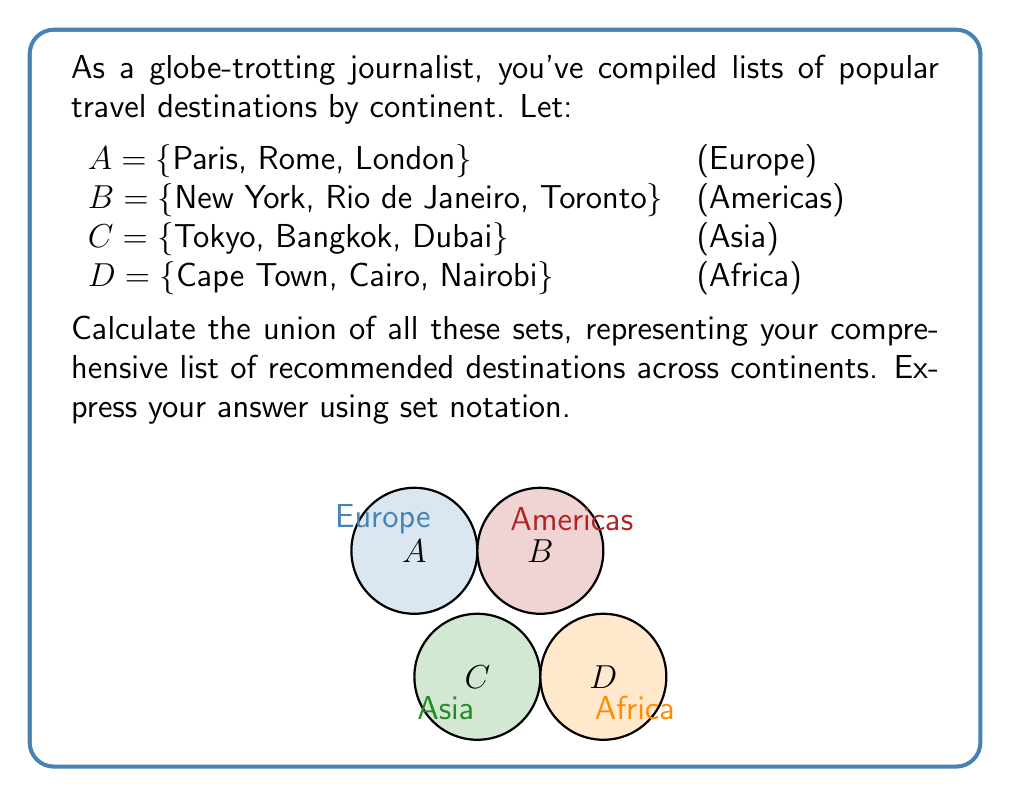Teach me how to tackle this problem. To calculate the union of these sets, we need to combine all unique elements from each set. The union operation is denoted by the symbol $\cup$. Let's approach this step-by-step:

1) First, let's recall the definition of union:
   The union of sets X and Y, denoted X $\cup$ Y, is the set of all elements that are in X, or in Y, or in both.

2) In our case, we need to find A $\cup$ B $\cup$ C $\cup$ D.

3) We can start by listing all elements from set A:
   {Paris, Rome, London}

4) Then, we add any new elements from set B:
   {Paris, Rome, London, New York, Rio de Janeiro, Toronto}

5) Next, we add any new elements from set C:
   {Paris, Rome, London, New York, Rio de Janeiro, Toronto, Tokyo, Bangkok, Dubai}

6) Finally, we add any new elements from set D:
   {Paris, Rome, London, New York, Rio de Janeiro, Toronto, Tokyo, Bangkok, Dubai, Cape Town, Cairo, Nairobi}

7) We can now express this as a set:
   A $\cup$ B $\cup$ C $\cup$ D = {Paris, Rome, London, New York, Rio de Janeiro, Toronto, Tokyo, Bangkok, Dubai, Cape Town, Cairo, Nairobi}

This set represents all unique destinations from the four original sets, giving a comprehensive list of recommended travel destinations across the four continents.
Answer: $$A \cup B \cup C \cup D = \{Paris, Rome, London, New York, Rio de Janeiro, Toronto, Tokyo, Bangkok, Dubai, Cape Town, Cairo, Nairobi\}$$ 